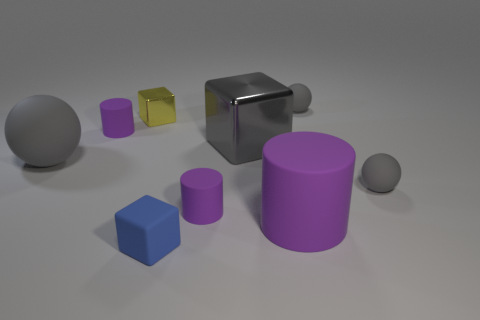Subtract all red blocks. Subtract all gray spheres. How many blocks are left? 3 Subtract all blocks. How many objects are left? 6 Add 1 rubber blocks. How many rubber blocks are left? 2 Add 5 gray things. How many gray things exist? 9 Subtract 3 gray spheres. How many objects are left? 6 Subtract all large purple things. Subtract all big gray metal things. How many objects are left? 7 